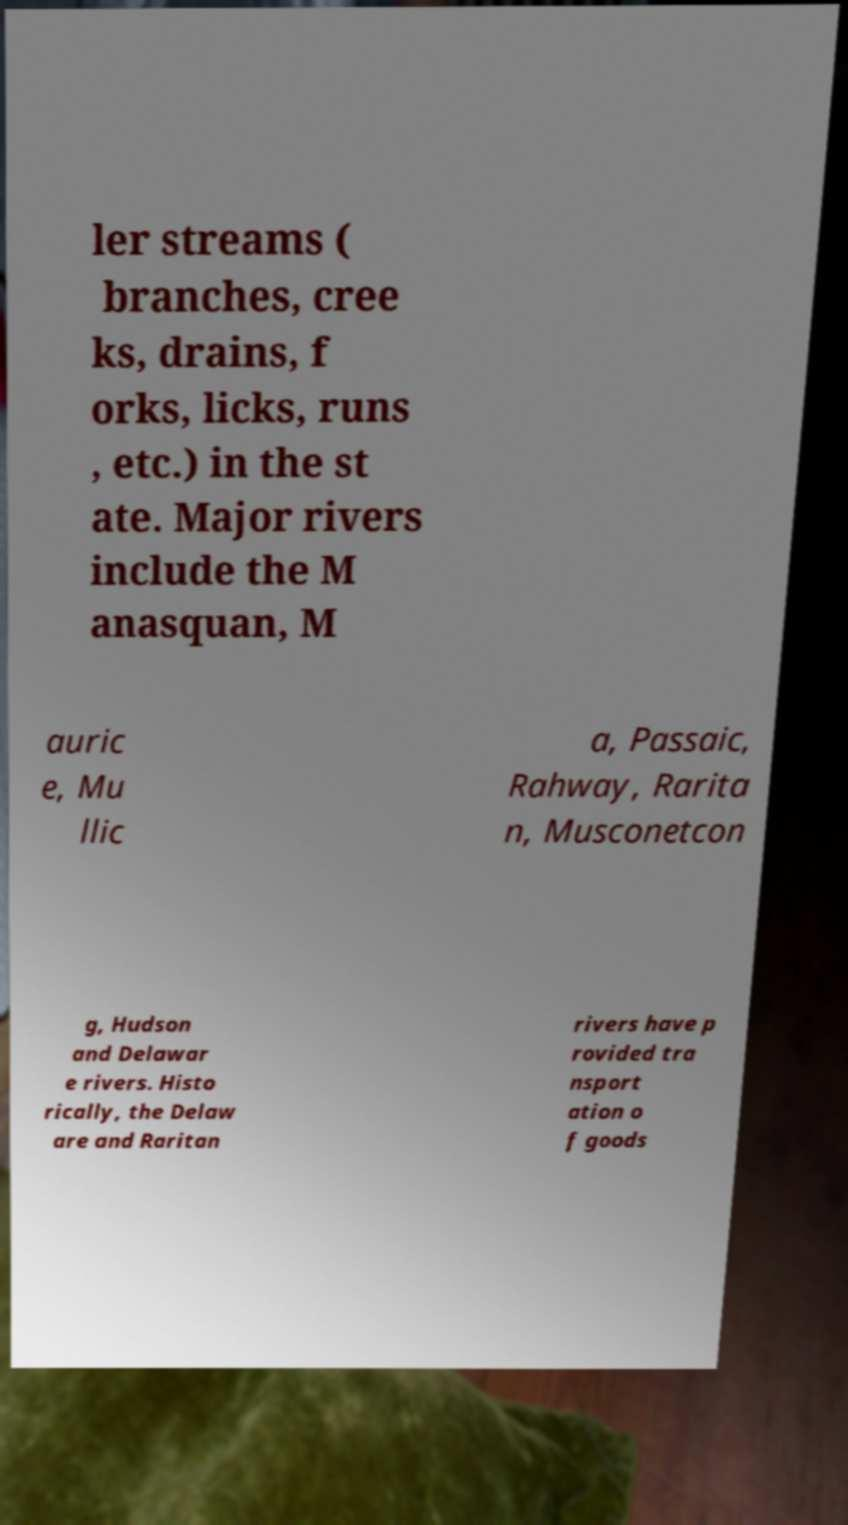Could you extract and type out the text from this image? ler streams ( branches, cree ks, drains, f orks, licks, runs , etc.) in the st ate. Major rivers include the M anasquan, M auric e, Mu llic a, Passaic, Rahway, Rarita n, Musconetcon g, Hudson and Delawar e rivers. Histo rically, the Delaw are and Raritan rivers have p rovided tra nsport ation o f goods 